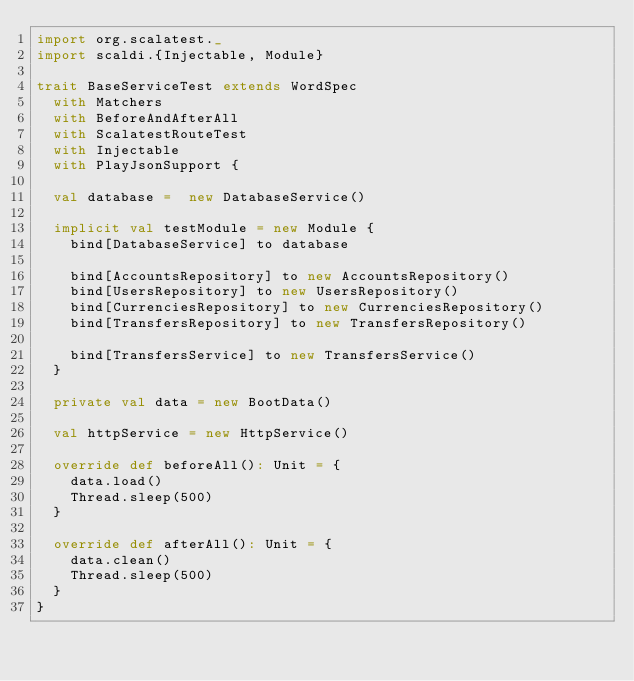Convert code to text. <code><loc_0><loc_0><loc_500><loc_500><_Scala_>import org.scalatest._
import scaldi.{Injectable, Module}

trait BaseServiceTest extends WordSpec
  with Matchers
  with BeforeAndAfterAll
  with ScalatestRouteTest
  with Injectable
  with PlayJsonSupport {

  val database =  new DatabaseService()

  implicit val testModule = new Module {
    bind[DatabaseService] to database

    bind[AccountsRepository] to new AccountsRepository()
    bind[UsersRepository] to new UsersRepository()
    bind[CurrenciesRepository] to new CurrenciesRepository()
    bind[TransfersRepository] to new TransfersRepository()

    bind[TransfersService] to new TransfersService()
  }

  private val data = new BootData()

  val httpService = new HttpService()

  override def beforeAll(): Unit = {
    data.load()
    Thread.sleep(500)
  }

  override def afterAll(): Unit = {
    data.clean()
    Thread.sleep(500)
  }
}
</code> 